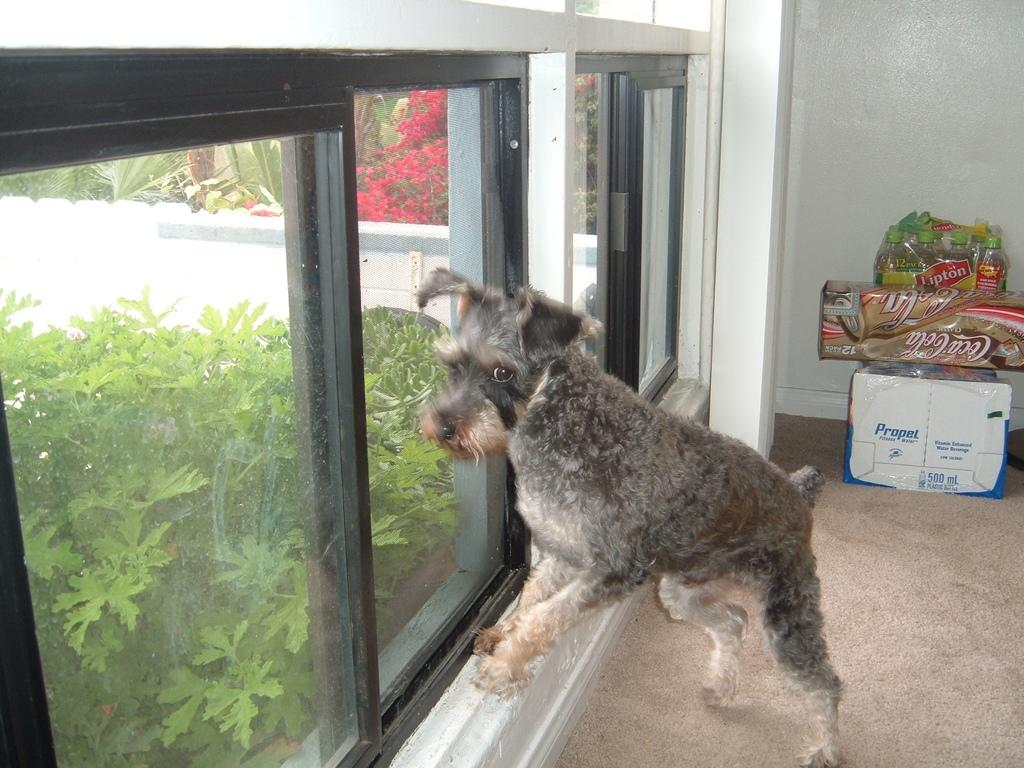What type of animal is present in the image? There is a dog in the image. What objects can be seen in the image besides the dog? There are boxes, bottles wrapped with a cover, and plants in the image. What architectural feature is visible in the image? There is a window in the image. What type of vegetation is present in the image? There are plants and trees in the image. What is the background of the image made of? There is a wall in the image. Where is the heart-shaped lunchroom in the image? There is no heart-shaped lunchroom present in the image. 